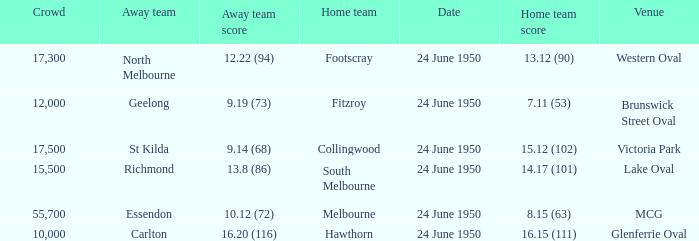Who was the home team for the game where North Melbourne was the away team and the crowd was over 12,000? Footscray. 